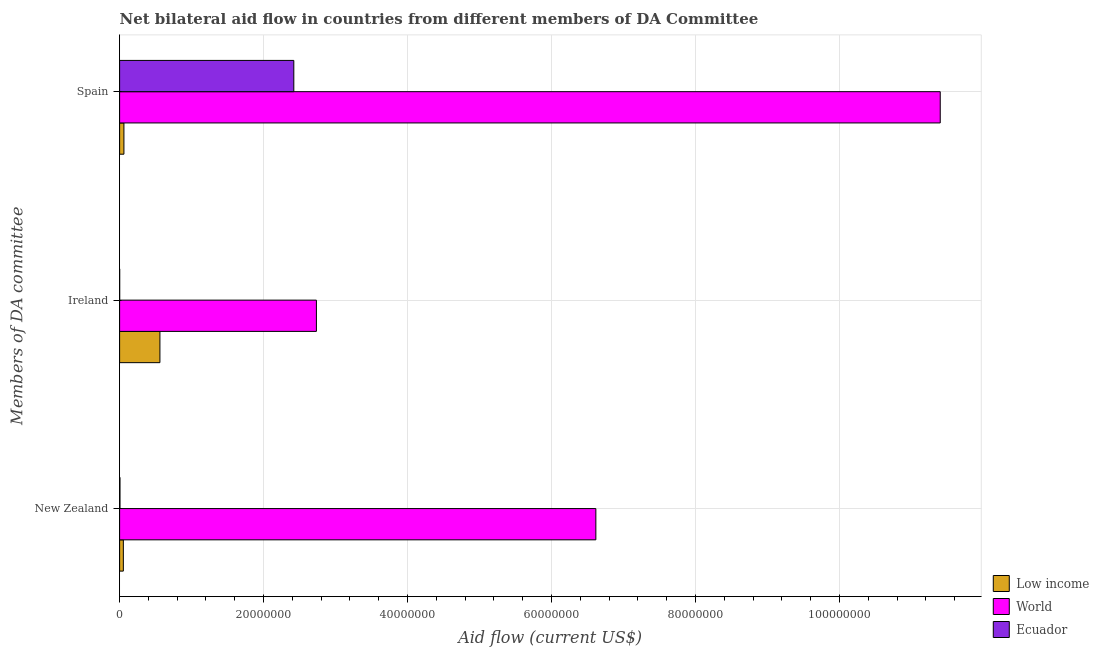How many different coloured bars are there?
Your response must be concise. 3. Are the number of bars on each tick of the Y-axis equal?
Give a very brief answer. Yes. How many bars are there on the 2nd tick from the top?
Offer a very short reply. 3. What is the amount of aid provided by spain in Ecuador?
Offer a terse response. 2.42e+07. Across all countries, what is the maximum amount of aid provided by spain?
Ensure brevity in your answer.  1.14e+08. Across all countries, what is the minimum amount of aid provided by new zealand?
Provide a succinct answer. 5.00e+04. In which country was the amount of aid provided by new zealand minimum?
Your answer should be very brief. Ecuador. What is the total amount of aid provided by new zealand in the graph?
Keep it short and to the point. 6.67e+07. What is the difference between the amount of aid provided by spain in Low income and that in World?
Give a very brief answer. -1.13e+08. What is the difference between the amount of aid provided by ireland in World and the amount of aid provided by new zealand in Low income?
Make the answer very short. 2.68e+07. What is the average amount of aid provided by new zealand per country?
Ensure brevity in your answer.  2.22e+07. What is the difference between the amount of aid provided by new zealand and amount of aid provided by ireland in Ecuador?
Ensure brevity in your answer.  4.00e+04. What is the ratio of the amount of aid provided by new zealand in Low income to that in World?
Offer a very short reply. 0.01. Is the amount of aid provided by spain in Ecuador less than that in World?
Offer a very short reply. Yes. Is the difference between the amount of aid provided by spain in World and Ecuador greater than the difference between the amount of aid provided by ireland in World and Ecuador?
Give a very brief answer. Yes. What is the difference between the highest and the second highest amount of aid provided by spain?
Offer a very short reply. 8.98e+07. What is the difference between the highest and the lowest amount of aid provided by ireland?
Provide a succinct answer. 2.73e+07. What does the 1st bar from the top in Spain represents?
Provide a succinct answer. Ecuador. What does the 1st bar from the bottom in Ireland represents?
Give a very brief answer. Low income. Is it the case that in every country, the sum of the amount of aid provided by new zealand and amount of aid provided by ireland is greater than the amount of aid provided by spain?
Ensure brevity in your answer.  No. How many countries are there in the graph?
Your answer should be compact. 3. How are the legend labels stacked?
Offer a terse response. Vertical. What is the title of the graph?
Your answer should be very brief. Net bilateral aid flow in countries from different members of DA Committee. Does "European Union" appear as one of the legend labels in the graph?
Give a very brief answer. No. What is the label or title of the Y-axis?
Ensure brevity in your answer.  Members of DA committee. What is the Aid flow (current US$) of Low income in New Zealand?
Offer a terse response. 5.20e+05. What is the Aid flow (current US$) of World in New Zealand?
Keep it short and to the point. 6.62e+07. What is the Aid flow (current US$) of Low income in Ireland?
Give a very brief answer. 5.60e+06. What is the Aid flow (current US$) in World in Ireland?
Your response must be concise. 2.73e+07. What is the Aid flow (current US$) in World in Spain?
Your response must be concise. 1.14e+08. What is the Aid flow (current US$) in Ecuador in Spain?
Offer a terse response. 2.42e+07. Across all Members of DA committee, what is the maximum Aid flow (current US$) in Low income?
Your response must be concise. 5.60e+06. Across all Members of DA committee, what is the maximum Aid flow (current US$) in World?
Provide a succinct answer. 1.14e+08. Across all Members of DA committee, what is the maximum Aid flow (current US$) of Ecuador?
Make the answer very short. 2.42e+07. Across all Members of DA committee, what is the minimum Aid flow (current US$) of Low income?
Offer a very short reply. 5.20e+05. Across all Members of DA committee, what is the minimum Aid flow (current US$) of World?
Offer a very short reply. 2.73e+07. What is the total Aid flow (current US$) in Low income in the graph?
Your response must be concise. 6.72e+06. What is the total Aid flow (current US$) of World in the graph?
Offer a terse response. 2.08e+08. What is the total Aid flow (current US$) in Ecuador in the graph?
Provide a succinct answer. 2.43e+07. What is the difference between the Aid flow (current US$) in Low income in New Zealand and that in Ireland?
Keep it short and to the point. -5.08e+06. What is the difference between the Aid flow (current US$) of World in New Zealand and that in Ireland?
Keep it short and to the point. 3.88e+07. What is the difference between the Aid flow (current US$) of World in New Zealand and that in Spain?
Your answer should be very brief. -4.78e+07. What is the difference between the Aid flow (current US$) in Ecuador in New Zealand and that in Spain?
Your answer should be very brief. -2.42e+07. What is the difference between the Aid flow (current US$) of Low income in Ireland and that in Spain?
Provide a succinct answer. 5.00e+06. What is the difference between the Aid flow (current US$) of World in Ireland and that in Spain?
Offer a very short reply. -8.67e+07. What is the difference between the Aid flow (current US$) of Ecuador in Ireland and that in Spain?
Your answer should be very brief. -2.42e+07. What is the difference between the Aid flow (current US$) in Low income in New Zealand and the Aid flow (current US$) in World in Ireland?
Your answer should be very brief. -2.68e+07. What is the difference between the Aid flow (current US$) in Low income in New Zealand and the Aid flow (current US$) in Ecuador in Ireland?
Give a very brief answer. 5.10e+05. What is the difference between the Aid flow (current US$) of World in New Zealand and the Aid flow (current US$) of Ecuador in Ireland?
Ensure brevity in your answer.  6.62e+07. What is the difference between the Aid flow (current US$) in Low income in New Zealand and the Aid flow (current US$) in World in Spain?
Provide a succinct answer. -1.13e+08. What is the difference between the Aid flow (current US$) in Low income in New Zealand and the Aid flow (current US$) in Ecuador in Spain?
Provide a succinct answer. -2.37e+07. What is the difference between the Aid flow (current US$) in World in New Zealand and the Aid flow (current US$) in Ecuador in Spain?
Ensure brevity in your answer.  4.20e+07. What is the difference between the Aid flow (current US$) of Low income in Ireland and the Aid flow (current US$) of World in Spain?
Offer a very short reply. -1.08e+08. What is the difference between the Aid flow (current US$) in Low income in Ireland and the Aid flow (current US$) in Ecuador in Spain?
Your answer should be compact. -1.86e+07. What is the difference between the Aid flow (current US$) of World in Ireland and the Aid flow (current US$) of Ecuador in Spain?
Your answer should be compact. 3.14e+06. What is the average Aid flow (current US$) of Low income per Members of DA committee?
Your answer should be compact. 2.24e+06. What is the average Aid flow (current US$) of World per Members of DA committee?
Offer a very short reply. 6.92e+07. What is the average Aid flow (current US$) of Ecuador per Members of DA committee?
Provide a short and direct response. 8.09e+06. What is the difference between the Aid flow (current US$) in Low income and Aid flow (current US$) in World in New Zealand?
Provide a short and direct response. -6.56e+07. What is the difference between the Aid flow (current US$) in World and Aid flow (current US$) in Ecuador in New Zealand?
Provide a short and direct response. 6.61e+07. What is the difference between the Aid flow (current US$) of Low income and Aid flow (current US$) of World in Ireland?
Offer a terse response. -2.17e+07. What is the difference between the Aid flow (current US$) of Low income and Aid flow (current US$) of Ecuador in Ireland?
Your answer should be very brief. 5.59e+06. What is the difference between the Aid flow (current US$) in World and Aid flow (current US$) in Ecuador in Ireland?
Offer a very short reply. 2.73e+07. What is the difference between the Aid flow (current US$) of Low income and Aid flow (current US$) of World in Spain?
Ensure brevity in your answer.  -1.13e+08. What is the difference between the Aid flow (current US$) of Low income and Aid flow (current US$) of Ecuador in Spain?
Make the answer very short. -2.36e+07. What is the difference between the Aid flow (current US$) of World and Aid flow (current US$) of Ecuador in Spain?
Offer a very short reply. 8.98e+07. What is the ratio of the Aid flow (current US$) in Low income in New Zealand to that in Ireland?
Ensure brevity in your answer.  0.09. What is the ratio of the Aid flow (current US$) of World in New Zealand to that in Ireland?
Keep it short and to the point. 2.42. What is the ratio of the Aid flow (current US$) in Low income in New Zealand to that in Spain?
Make the answer very short. 0.87. What is the ratio of the Aid flow (current US$) in World in New Zealand to that in Spain?
Give a very brief answer. 0.58. What is the ratio of the Aid flow (current US$) in Ecuador in New Zealand to that in Spain?
Your answer should be compact. 0. What is the ratio of the Aid flow (current US$) of Low income in Ireland to that in Spain?
Offer a very short reply. 9.33. What is the ratio of the Aid flow (current US$) in World in Ireland to that in Spain?
Give a very brief answer. 0.24. What is the ratio of the Aid flow (current US$) in Ecuador in Ireland to that in Spain?
Keep it short and to the point. 0. What is the difference between the highest and the second highest Aid flow (current US$) of World?
Offer a terse response. 4.78e+07. What is the difference between the highest and the second highest Aid flow (current US$) in Ecuador?
Your answer should be very brief. 2.42e+07. What is the difference between the highest and the lowest Aid flow (current US$) in Low income?
Offer a very short reply. 5.08e+06. What is the difference between the highest and the lowest Aid flow (current US$) in World?
Provide a succinct answer. 8.67e+07. What is the difference between the highest and the lowest Aid flow (current US$) of Ecuador?
Your answer should be very brief. 2.42e+07. 